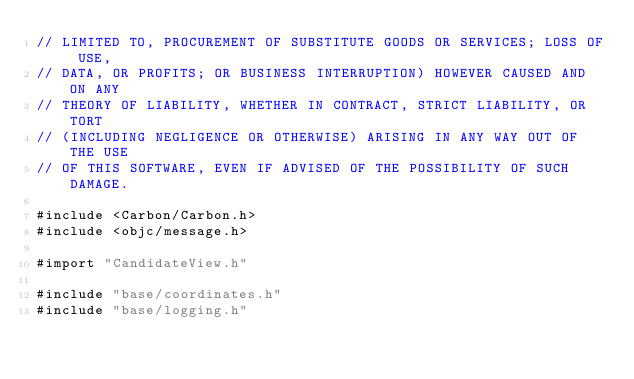Convert code to text. <code><loc_0><loc_0><loc_500><loc_500><_ObjectiveC_>// LIMITED TO, PROCUREMENT OF SUBSTITUTE GOODS OR SERVICES; LOSS OF USE,
// DATA, OR PROFITS; OR BUSINESS INTERRUPTION) HOWEVER CAUSED AND ON ANY
// THEORY OF LIABILITY, WHETHER IN CONTRACT, STRICT LIABILITY, OR TORT
// (INCLUDING NEGLIGENCE OR OTHERWISE) ARISING IN ANY WAY OUT OF THE USE
// OF THIS SOFTWARE, EVEN IF ADVISED OF THE POSSIBILITY OF SUCH DAMAGE.

#include <Carbon/Carbon.h>
#include <objc/message.h>

#import "CandidateView.h"

#include "base/coordinates.h"
#include "base/logging.h"</code> 